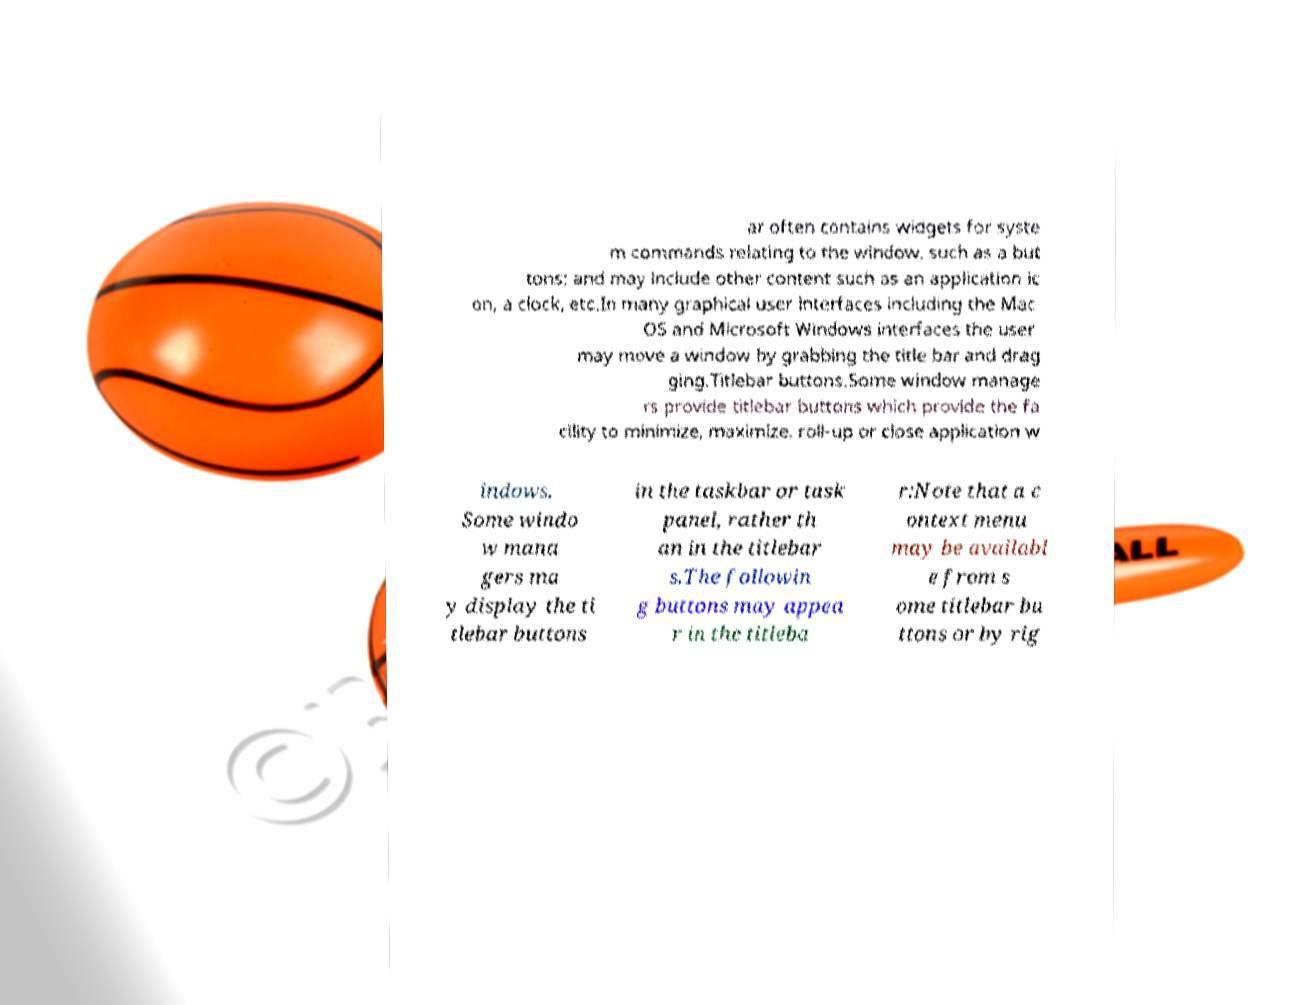For documentation purposes, I need the text within this image transcribed. Could you provide that? ar often contains widgets for syste m commands relating to the window, such as a but tons; and may include other content such as an application ic on, a clock, etc.In many graphical user interfaces including the Mac OS and Microsoft Windows interfaces the user may move a window by grabbing the title bar and drag ging.Titlebar buttons.Some window manage rs provide titlebar buttons which provide the fa cility to minimize, maximize, roll-up or close application w indows. Some windo w mana gers ma y display the ti tlebar buttons in the taskbar or task panel, rather th an in the titlebar s.The followin g buttons may appea r in the titleba r:Note that a c ontext menu may be availabl e from s ome titlebar bu ttons or by rig 